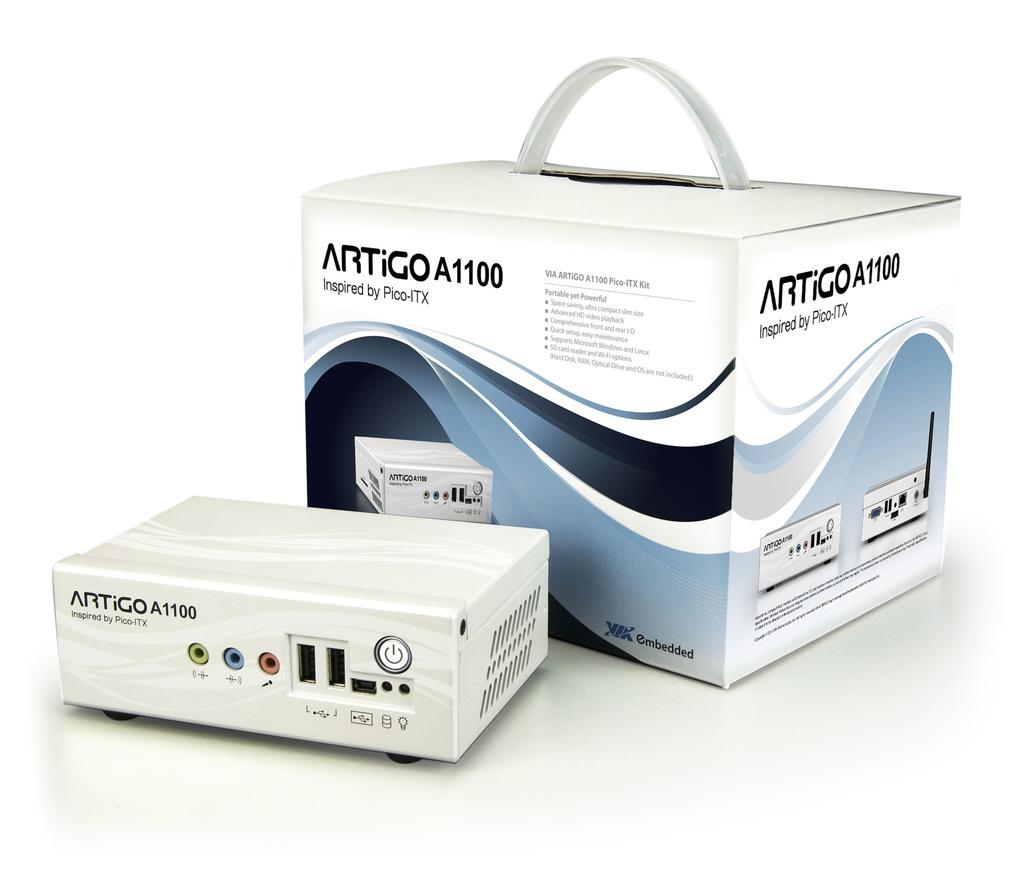<image>
Provide a brief description of the given image. a box and product of ARTiGO A1100 Inspired by Pico-ITX 